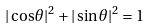Convert formula to latex. <formula><loc_0><loc_0><loc_500><loc_500>| \cos \theta | ^ { 2 } + | \sin \theta | ^ { 2 } = 1</formula> 